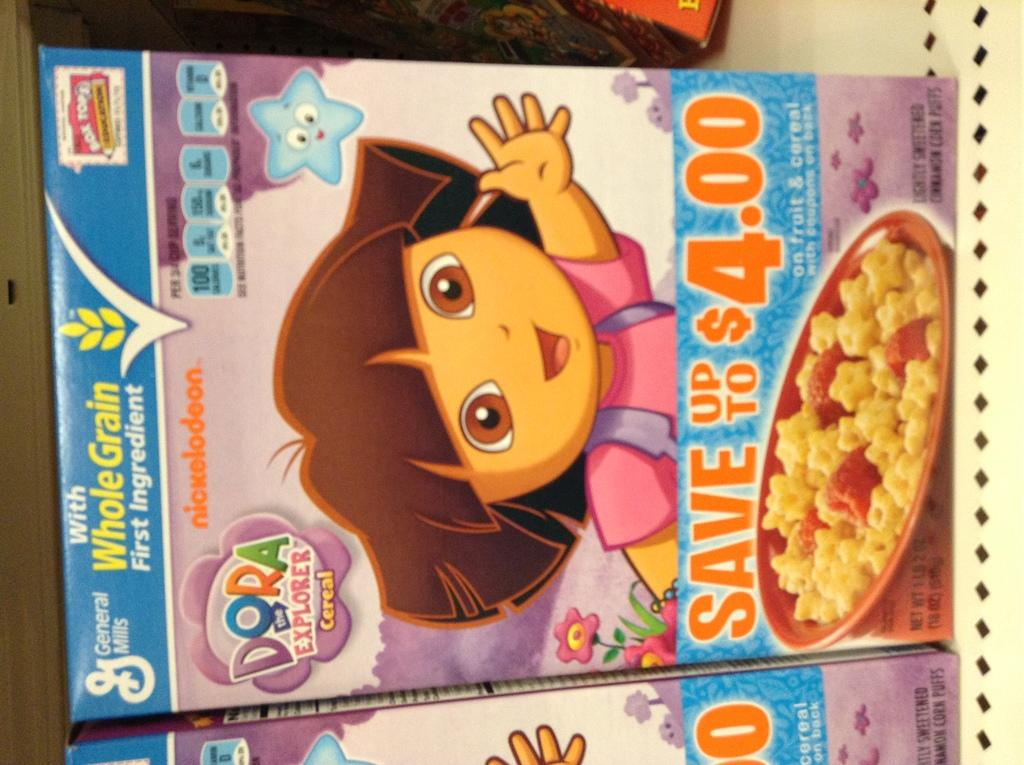What can be seen in the image? There are two cereal boxes in the image. How are the cereal boxes positioned in relation to each other? The cereal boxes are beside each other. What do the cereal boxes have on them? The cereal boxes have graphic images on them. How is the image oriented? The image is vertical. What type of needle is being used to sew the frame in the image? There is no needle or frame present in the image; it only features two cereal boxes. 